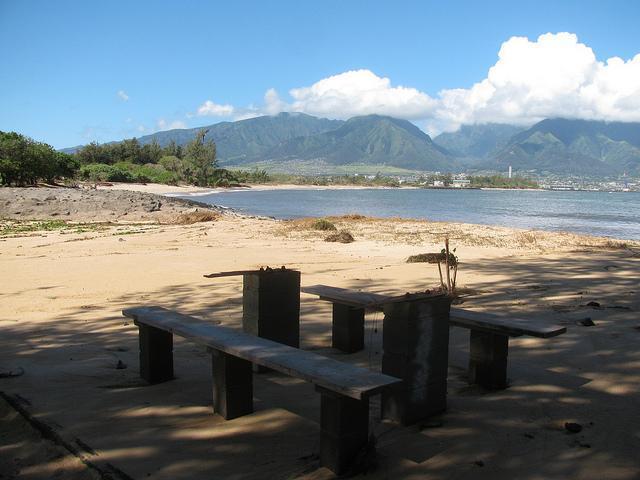How many benches are there?
Give a very brief answer. 2. 